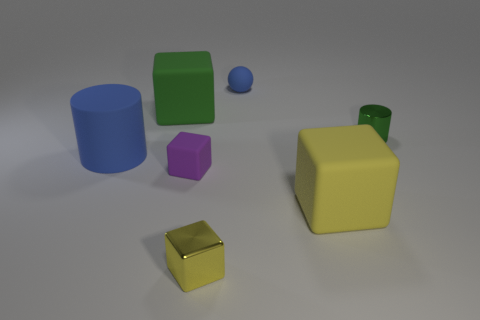Subtract 1 cubes. How many cubes are left? 3 Add 2 big red matte spheres. How many objects exist? 9 Subtract all cubes. How many objects are left? 3 Add 4 purple things. How many purple things exist? 5 Subtract 0 brown blocks. How many objects are left? 7 Subtract all gray matte spheres. Subtract all large yellow things. How many objects are left? 6 Add 5 small blue spheres. How many small blue spheres are left? 6 